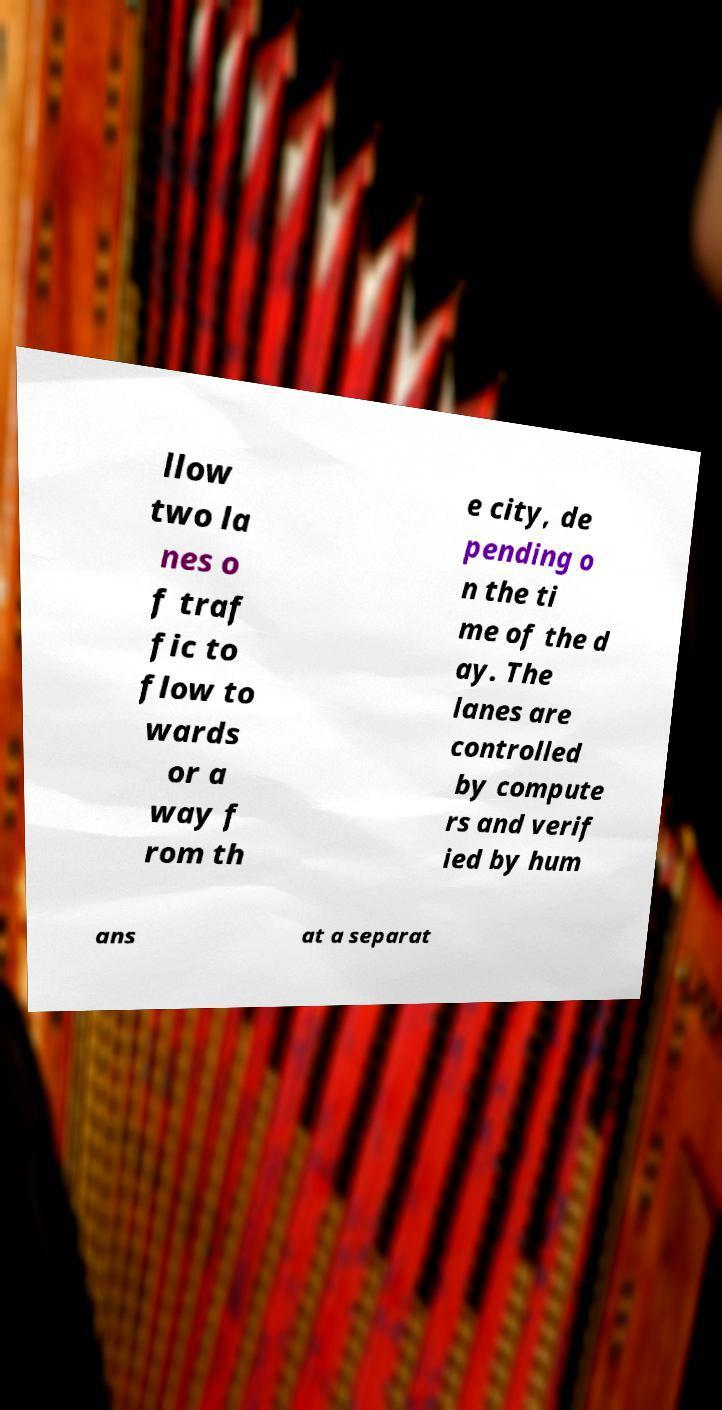Please read and relay the text visible in this image. What does it say? llow two la nes o f traf fic to flow to wards or a way f rom th e city, de pending o n the ti me of the d ay. The lanes are controlled by compute rs and verif ied by hum ans at a separat 